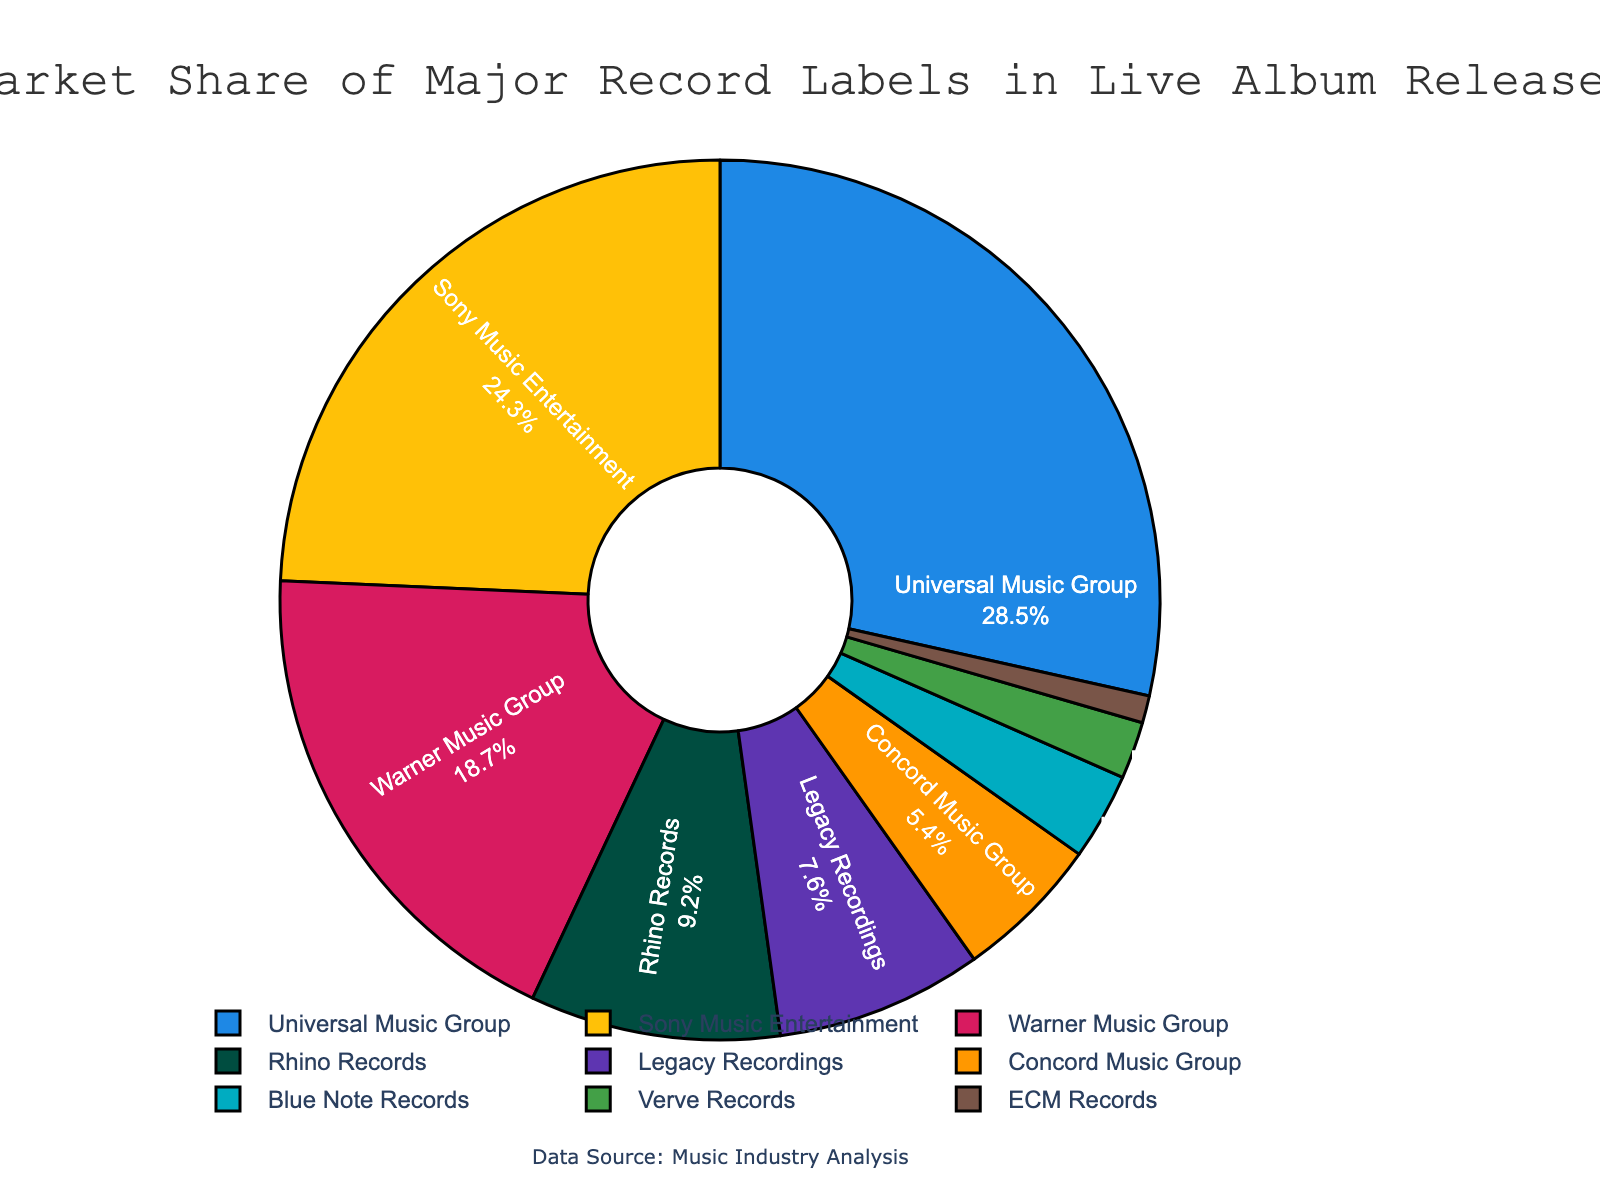What is the market share of the Universal Music Group? Look at the segment in the pie chart labeled "Universal Music Group." The percentage shown in that segment is its market share.
Answer: 28.5% Which record label has a higher market share: Warner Music Group or Sony Music Entertainment? Compare the segments labeled "Warner Music Group" and "Sony Music Entertainment." The percentage shown for Warner Music Group is 18.7%, while for Sony Music it is 24.3%.
Answer: Sony Music Entertainment What is the combined market share of Rhino Records and Legacy Recordings? Locate the segments labeled "Rhino Records" and "Legacy Recordings." Their respective percentages (9.2% and 7.6%) should be added together: 9.2 + 7.6 = 16.8.
Answer: 16.8% How much more market share does Universal Music Group have compared to Blue Note Records? Find the market shares of "Universal Music Group" (28.5%) and "Blue Note Records" (3.2%), then subtract the latter from the former: 28.5 - 3.2 = 25.3.
Answer: 25.3% Which label contributes the least to the market share of live album releases? Look for the smallest segment in the pie chart. The label with the smallest percentage is "ECM Records."
Answer: ECM Records What is the average market share of Concord Music Group, Verve Records, and ECM Records combined? Locate the market shares of "Concord Music Group" (5.4%), "Verve Records" (2.1%), and "ECM Records" (1.0%) and compute the average: (5.4 + 2.1 + 1.0) / 3 = 2.83.
Answer: 2.83% Which record label's segment in the pie chart is represented by the color blue? Observe the color coded segments in the pie chart. The segment with the color blue represents "Universal Music Group."
Answer: Universal Music Group Combine the market shares of the three smallest record labels in the chart. What is the total? Identify the market shares of the three smallest segments: "ECM Records" (1.0%), "Verve Records" (2.1%), and "Blue Note Records" (3.2%). Their sum is: 1.0 + 2.1 + 3.2 = 6.3.
Answer: 6.3 Is the market share of Universal Music Group greater than the combined market share of Legacy Recordings, Concord Music Group, and Blue Note Records? First, find the combined market share of "Legacy Recordings" (7.6%), "Concord Music Group" (5.4%), and "Blue Note Records" (3.2%): 7.6 + 5.4 + 3.2 = 16.2. Compare this with "Universal Music Group" (28.5%): 28.5 > 16.2.
Answer: Yes 